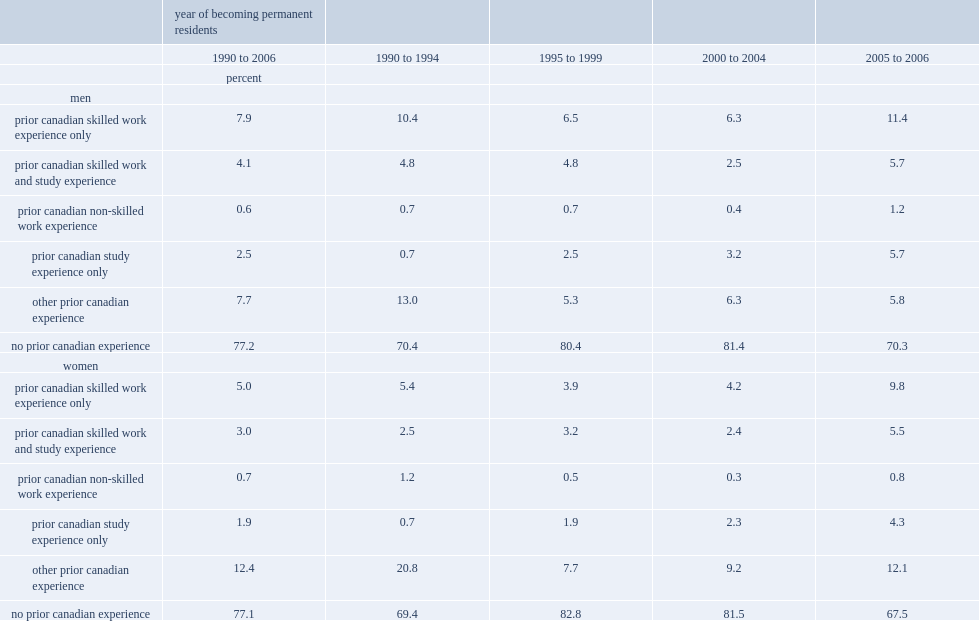Among male economic immigrants in the study sample who landed between 1990 and 2006, how many percentage of those had some prior canadian experience? 22.8. Among men who landed in the early 1990s, how many percentage of those had some prior canadian experience? 29.6. Among men who landed in the late 1990s and early 2000s, how many percentage of those had some prior canadian experience? 19.8. Among men who landed over the period from 2005 to 2006, how many percentage of those had some prior canadian experience? 29.8. By 2005/2006, how many percentage of immigrant men with only canadian study experience accounted for immigrants with prior canadian experience? 0.191275. 